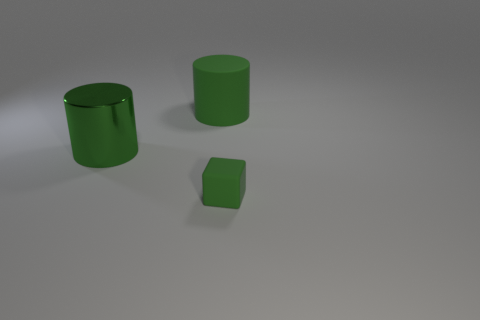Add 1 large cyan rubber balls. How many objects exist? 4 Subtract all cubes. How many objects are left? 2 Add 1 green matte cubes. How many green matte cubes exist? 2 Subtract 0 yellow cylinders. How many objects are left? 3 Subtract all metallic cylinders. Subtract all small green matte blocks. How many objects are left? 1 Add 3 large objects. How many large objects are left? 5 